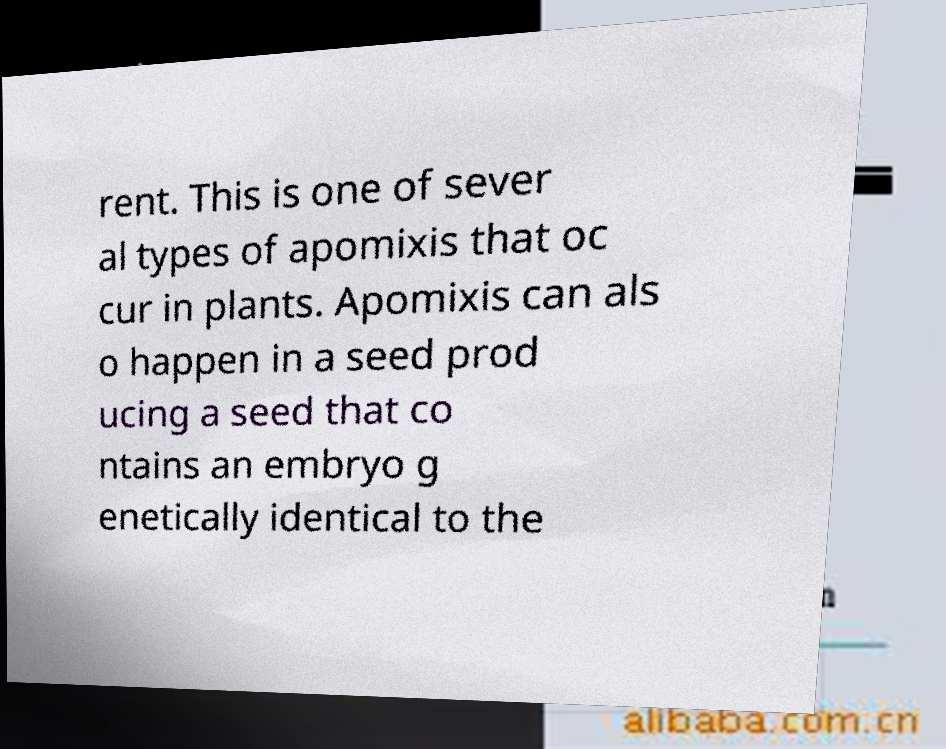Could you assist in decoding the text presented in this image and type it out clearly? rent. This is one of sever al types of apomixis that oc cur in plants. Apomixis can als o happen in a seed prod ucing a seed that co ntains an embryo g enetically identical to the 